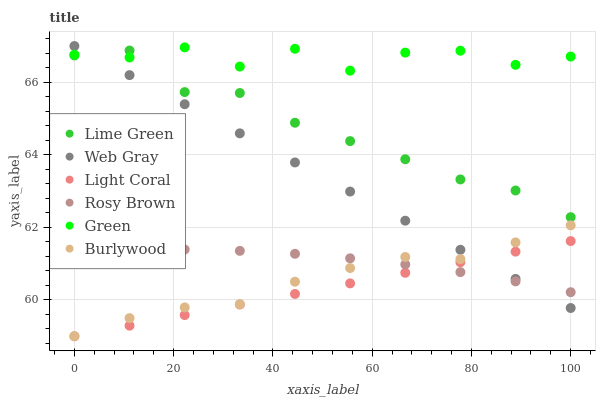Does Light Coral have the minimum area under the curve?
Answer yes or no. Yes. Does Green have the maximum area under the curve?
Answer yes or no. Yes. Does Burlywood have the minimum area under the curve?
Answer yes or no. No. Does Burlywood have the maximum area under the curve?
Answer yes or no. No. Is Light Coral the smoothest?
Answer yes or no. Yes. Is Green the roughest?
Answer yes or no. Yes. Is Burlywood the smoothest?
Answer yes or no. No. Is Burlywood the roughest?
Answer yes or no. No. Does Burlywood have the lowest value?
Answer yes or no. Yes. Does Rosy Brown have the lowest value?
Answer yes or no. No. Does Web Gray have the highest value?
Answer yes or no. Yes. Does Burlywood have the highest value?
Answer yes or no. No. Is Light Coral less than Green?
Answer yes or no. Yes. Is Lime Green greater than Rosy Brown?
Answer yes or no. Yes. Does Rosy Brown intersect Light Coral?
Answer yes or no. Yes. Is Rosy Brown less than Light Coral?
Answer yes or no. No. Is Rosy Brown greater than Light Coral?
Answer yes or no. No. Does Light Coral intersect Green?
Answer yes or no. No. 